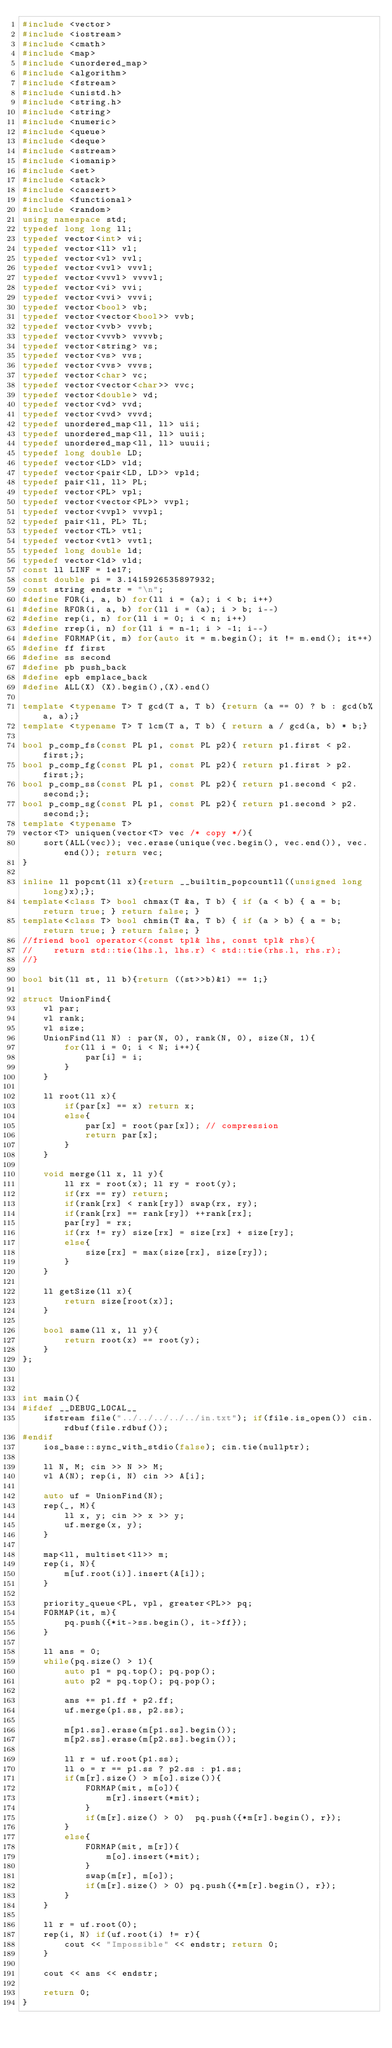<code> <loc_0><loc_0><loc_500><loc_500><_C++_>#include <vector>
#include <iostream>
#include <cmath>
#include <map>
#include <unordered_map>
#include <algorithm>
#include <fstream>
#include <unistd.h>
#include <string.h>
#include <string>
#include <numeric>
#include <queue>
#include <deque>
#include <sstream>
#include <iomanip>
#include <set>
#include <stack>
#include <cassert>
#include <functional>
#include <random>
using namespace std;
typedef long long ll;
typedef vector<int> vi;
typedef vector<ll> vl;
typedef vector<vl> vvl;
typedef vector<vvl> vvvl;
typedef vector<vvvl> vvvvl;
typedef vector<vi> vvi;
typedef vector<vvi> vvvi;
typedef vector<bool> vb;
typedef vector<vector<bool>> vvb;
typedef vector<vvb> vvvb;
typedef vector<vvvb> vvvvb;
typedef vector<string> vs;
typedef vector<vs> vvs;
typedef vector<vvs> vvvs;
typedef vector<char> vc;
typedef vector<vector<char>> vvc;
typedef vector<double> vd;
typedef vector<vd> vvd;
typedef vector<vvd> vvvd;
typedef unordered_map<ll, ll> uii;
typedef unordered_map<ll, ll> uuii;
typedef unordered_map<ll, ll> uuuii;
typedef long double LD;
typedef vector<LD> vld;
typedef vector<pair<LD, LD>> vpld;
typedef pair<ll, ll> PL;
typedef vector<PL> vpl;
typedef vector<vector<PL>> vvpl;
typedef vector<vvpl> vvvpl;
typedef pair<ll, PL> TL;
typedef vector<TL> vtl;
typedef vector<vtl> vvtl;
typedef long double ld;
typedef vector<ld> vld;
const ll LINF = 1e17;
const double pi = 3.1415926535897932;
const string endstr = "\n";
#define FOR(i, a, b) for(ll i = (a); i < b; i++)
#define RFOR(i, a, b) for(ll i = (a); i > b; i--)
#define rep(i, n) for(ll i = 0; i < n; i++)
#define rrep(i, n) for(ll i = n-1; i > -1; i--)
#define FORMAP(it, m) for(auto it = m.begin(); it != m.end(); it++)
#define ff first
#define ss second
#define pb push_back
#define epb emplace_back
#define ALL(X) (X).begin(),(X).end()

template <typename T> T gcd(T a, T b) {return (a == 0) ? b : gcd(b%a, a);}
template <typename T> T lcm(T a, T b) { return a / gcd(a, b) * b;}

bool p_comp_fs(const PL p1, const PL p2){ return p1.first < p2.first;};
bool p_comp_fg(const PL p1, const PL p2){ return p1.first > p2.first;};
bool p_comp_ss(const PL p1, const PL p2){ return p1.second < p2.second;};
bool p_comp_sg(const PL p1, const PL p2){ return p1.second > p2.second;};
template <typename T>
vector<T> uniquen(vector<T> vec /* copy */){
    sort(ALL(vec)); vec.erase(unique(vec.begin(), vec.end()), vec.end()); return vec;
}

inline ll popcnt(ll x){return __builtin_popcountll((unsigned long long)x);};
template<class T> bool chmax(T &a, T b) { if (a < b) { a = b; return true; } return false; }
template<class T> bool chmin(T &a, T b) { if (a > b) { a = b; return true; } return false; }
//friend bool operator<(const tpl& lhs, const tpl& rhs){
//    return std::tie(lhs.l, lhs.r) < std::tie(rhs.l, rhs.r);
//}

bool bit(ll st, ll b){return ((st>>b)&1) == 1;}

struct UnionFind{
    vl par;
    vl rank;
    vl size;
    UnionFind(ll N) : par(N, 0), rank(N, 0), size(N, 1){
        for(ll i = 0; i < N; i++){
            par[i] = i;
        }
    }
    
    ll root(ll x){
        if(par[x] == x) return x;
        else{
            par[x] = root(par[x]); // compression
            return par[x];
        }
    }
    
    void merge(ll x, ll y){
        ll rx = root(x); ll ry = root(y);
        if(rx == ry) return;
        if(rank[rx] < rank[ry]) swap(rx, ry);
        if(rank[rx] == rank[ry]) ++rank[rx];
        par[ry] = rx;
        if(rx != ry) size[rx] = size[rx] + size[ry];
        else{
            size[rx] = max(size[rx], size[ry]);
        }
    }
    
    ll getSize(ll x){
        return size[root(x)];
    }
    
    bool same(ll x, ll y){
        return root(x) == root(y);
    }
};



int main(){
#ifdef __DEBUG_LOCAL__
    ifstream file("../../../../../in.txt"); if(file.is_open()) cin.rdbuf(file.rdbuf());
#endif
    ios_base::sync_with_stdio(false); cin.tie(nullptr);
    
    ll N, M; cin >> N >> M;
    vl A(N); rep(i, N) cin >> A[i];
    
    auto uf = UnionFind(N);
    rep(_, M){
        ll x, y; cin >> x >> y;
        uf.merge(x, y);
    }
    
    map<ll, multiset<ll>> m;
    rep(i, N){
        m[uf.root(i)].insert(A[i]);
    }
    
    priority_queue<PL, vpl, greater<PL>> pq;
    FORMAP(it, m){
        pq.push({*it->ss.begin(), it->ff});
    }
    
    ll ans = 0;
    while(pq.size() > 1){
        auto p1 = pq.top(); pq.pop();
        auto p2 = pq.top(); pq.pop();
        
        ans += p1.ff + p2.ff;
        uf.merge(p1.ss, p2.ss);
        
        m[p1.ss].erase(m[p1.ss].begin());
        m[p2.ss].erase(m[p2.ss].begin());
        
        ll r = uf.root(p1.ss);
        ll o = r == p1.ss ? p2.ss : p1.ss;
        if(m[r].size() > m[o].size()){
            FORMAP(mit, m[o]){
                m[r].insert(*mit);
            }
            if(m[r].size() > 0)  pq.push({*m[r].begin(), r});
        }
        else{
            FORMAP(mit, m[r]){
                m[o].insert(*mit);
            }
            swap(m[r], m[o]);
            if(m[r].size() > 0) pq.push({*m[r].begin(), r});
        }
    }
    
    ll r = uf.root(0);
    rep(i, N) if(uf.root(i) != r){
        cout << "Impossible" << endstr; return 0;
    }
    
    cout << ans << endstr;
    
    return 0;
}
</code> 